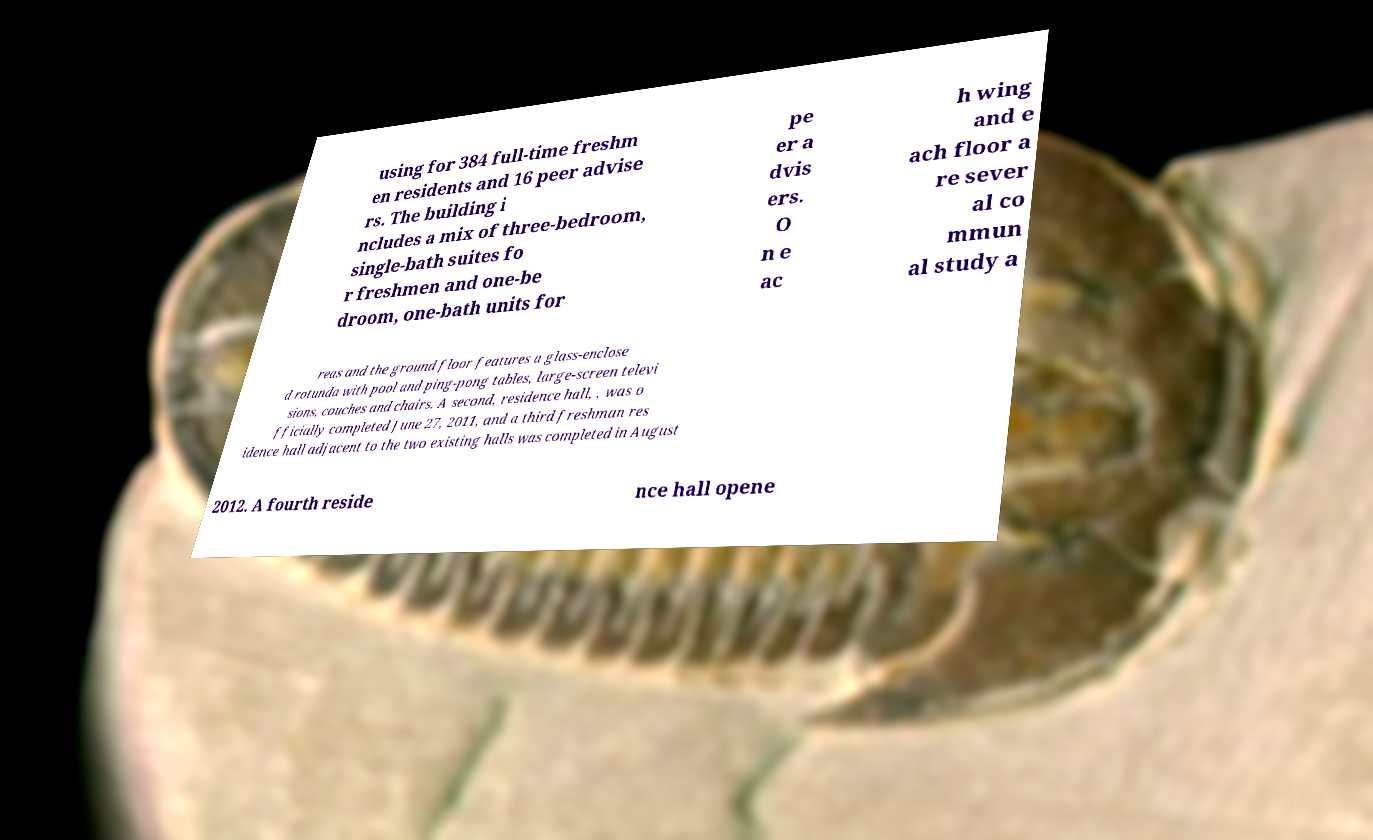Please read and relay the text visible in this image. What does it say? using for 384 full-time freshm en residents and 16 peer advise rs. The building i ncludes a mix of three-bedroom, single-bath suites fo r freshmen and one-be droom, one-bath units for pe er a dvis ers. O n e ac h wing and e ach floor a re sever al co mmun al study a reas and the ground floor features a glass-enclose d rotunda with pool and ping-pong tables, large-screen televi sions, couches and chairs. A second, residence hall, , was o fficially completed June 27, 2011, and a third freshman res idence hall adjacent to the two existing halls was completed in August 2012. A fourth reside nce hall opene 